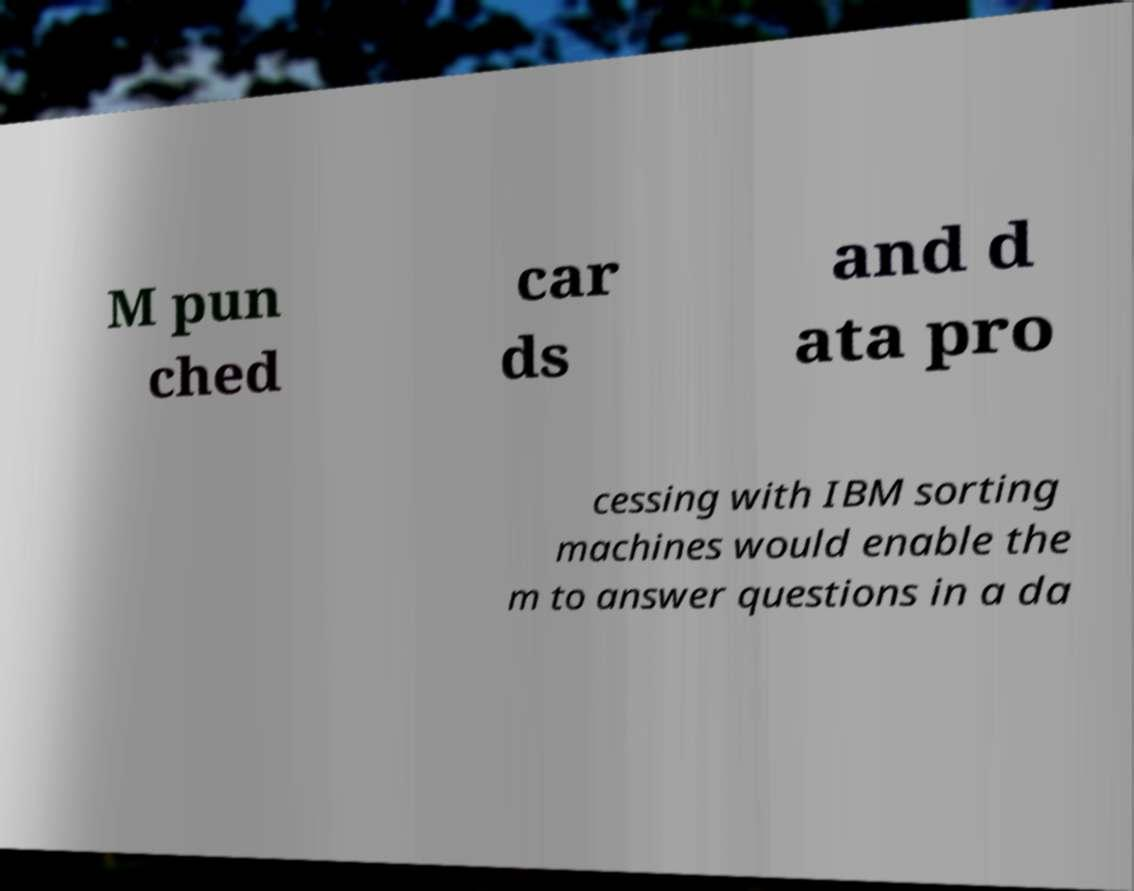Please identify and transcribe the text found in this image. M pun ched car ds and d ata pro cessing with IBM sorting machines would enable the m to answer questions in a da 